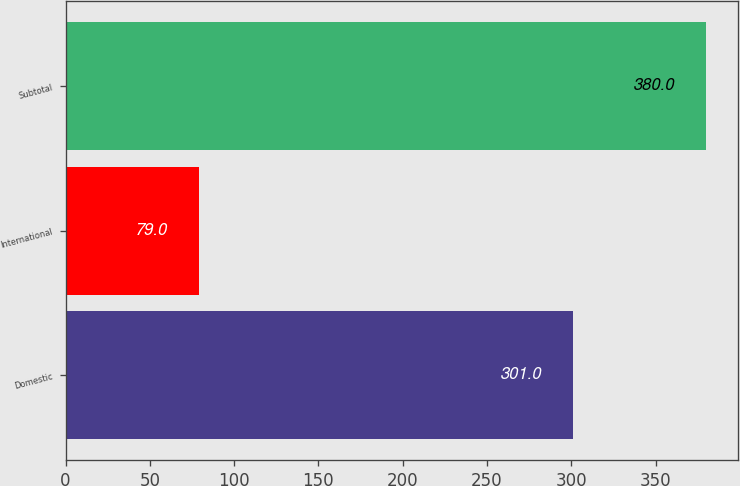<chart> <loc_0><loc_0><loc_500><loc_500><bar_chart><fcel>Domestic<fcel>International<fcel>Subtotal<nl><fcel>301<fcel>79<fcel>380<nl></chart> 